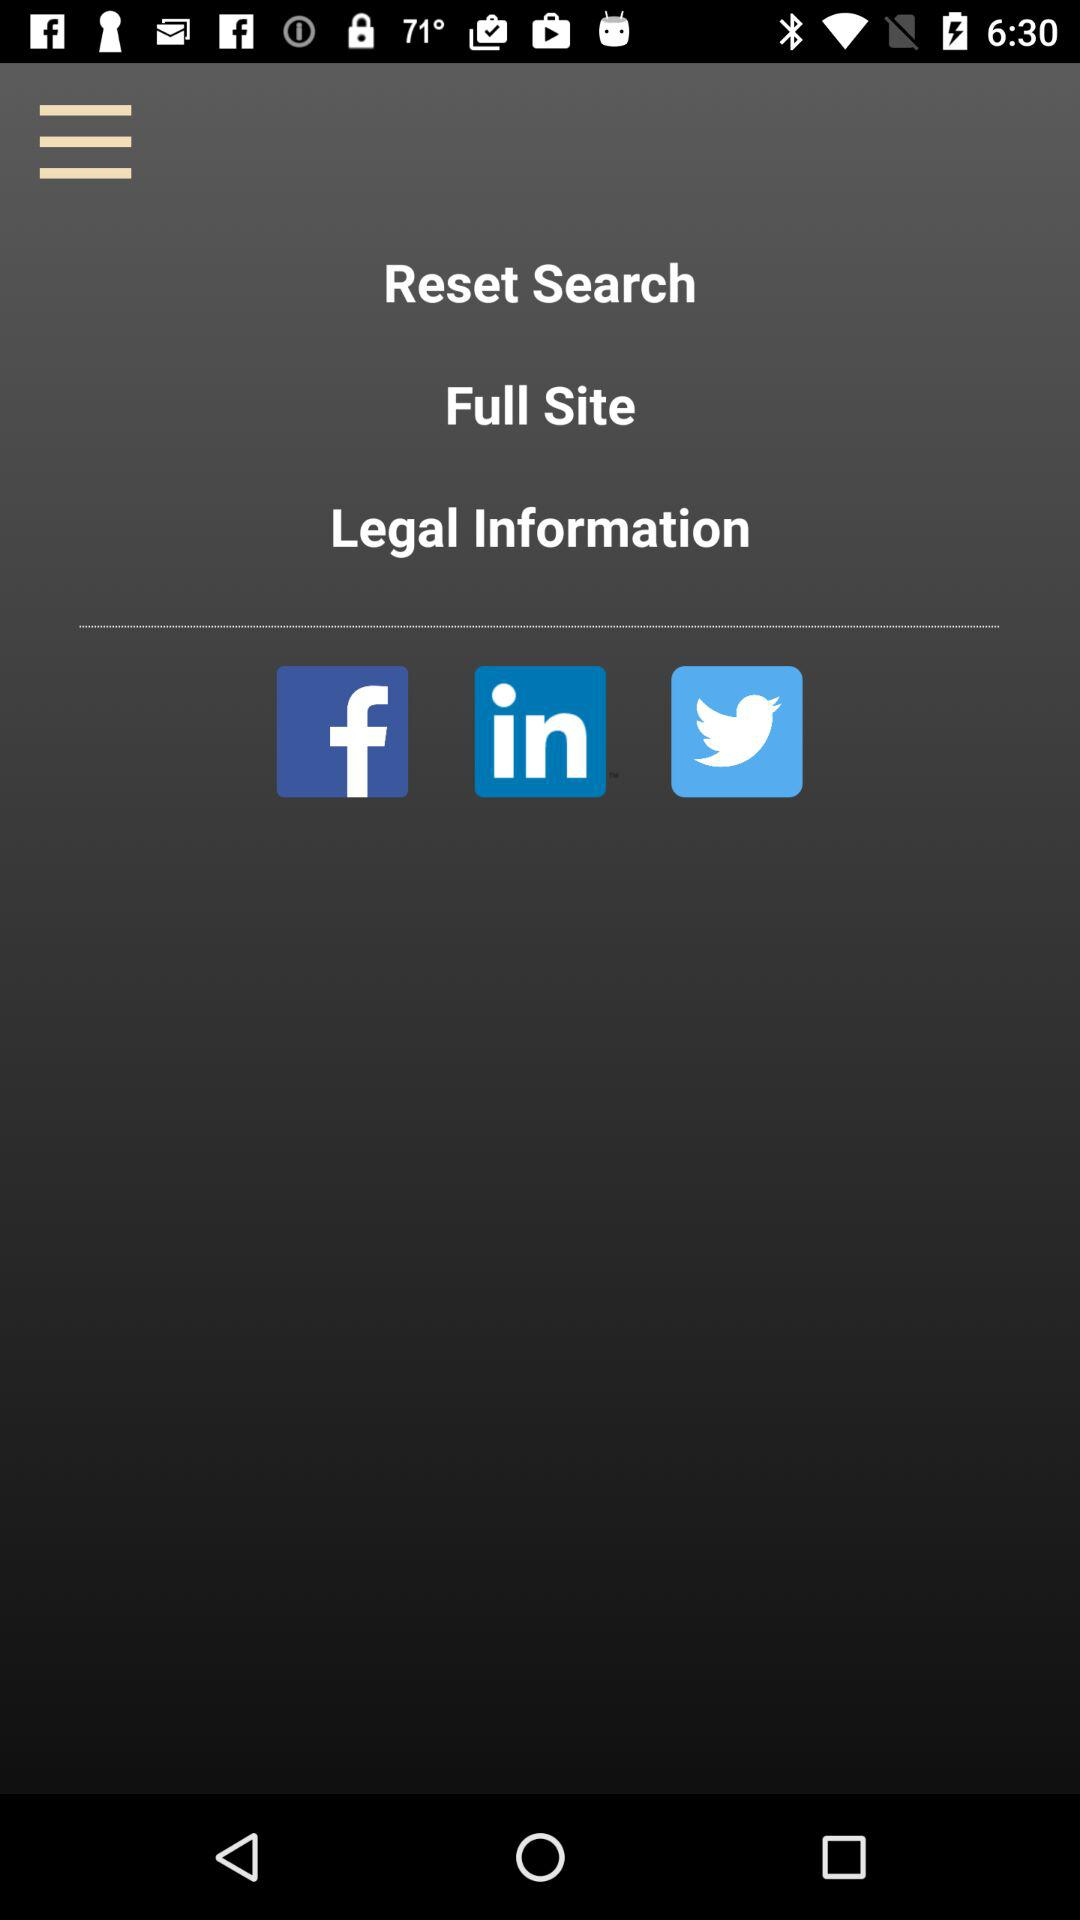What are the given applications? The given applications are "Facebook", "LinkedIn" and "Twitter". 